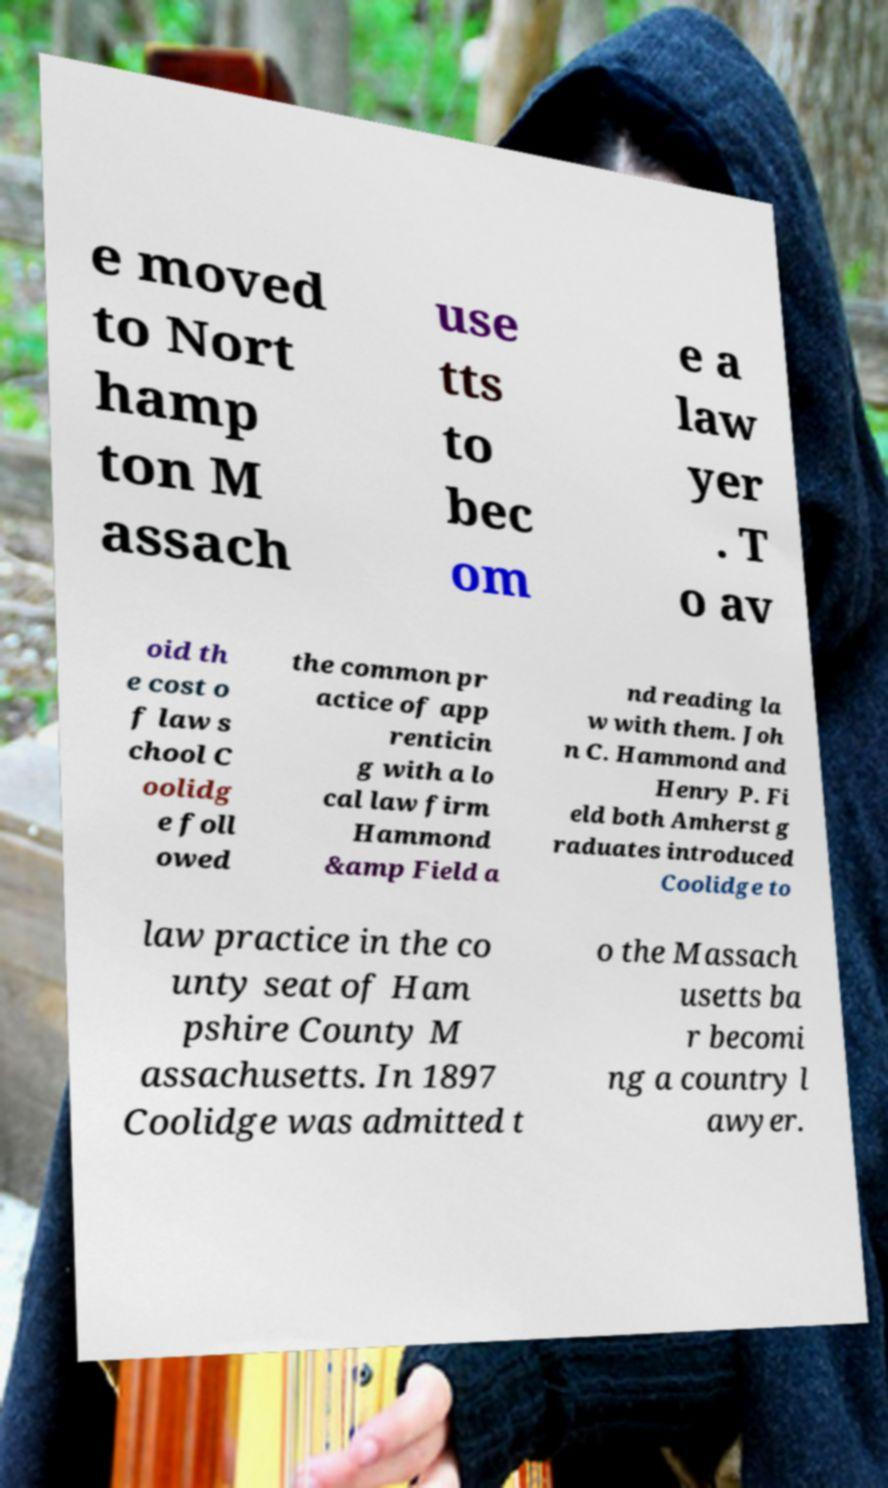Please read and relay the text visible in this image. What does it say? e moved to Nort hamp ton M assach use tts to bec om e a law yer . T o av oid th e cost o f law s chool C oolidg e foll owed the common pr actice of app renticin g with a lo cal law firm Hammond &amp Field a nd reading la w with them. Joh n C. Hammond and Henry P. Fi eld both Amherst g raduates introduced Coolidge to law practice in the co unty seat of Ham pshire County M assachusetts. In 1897 Coolidge was admitted t o the Massach usetts ba r becomi ng a country l awyer. 